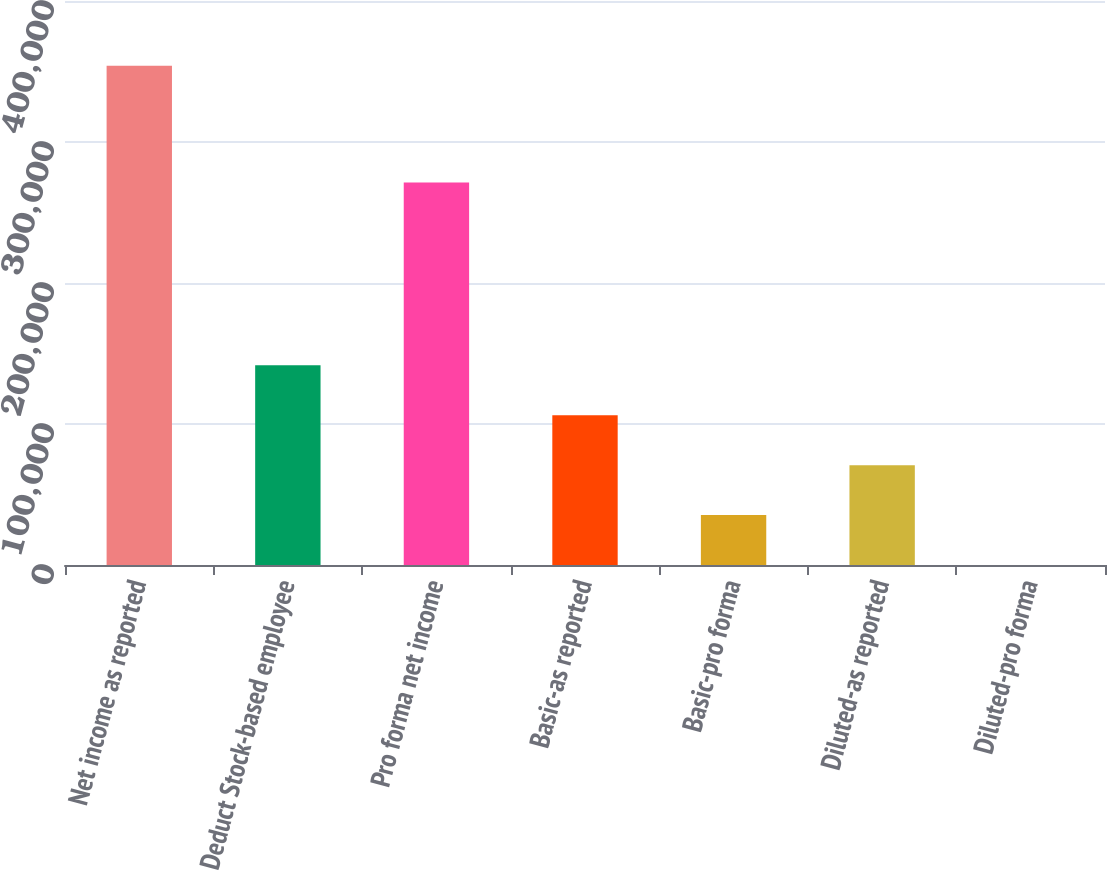<chart> <loc_0><loc_0><loc_500><loc_500><bar_chart><fcel>Net income as reported<fcel>Deduct Stock-based employee<fcel>Pro forma net income<fcel>Basic-as reported<fcel>Basic-pro forma<fcel>Diluted-as reported<fcel>Diluted-pro forma<nl><fcel>354149<fcel>141660<fcel>271193<fcel>106245<fcel>35415.6<fcel>70830.4<fcel>0.76<nl></chart> 